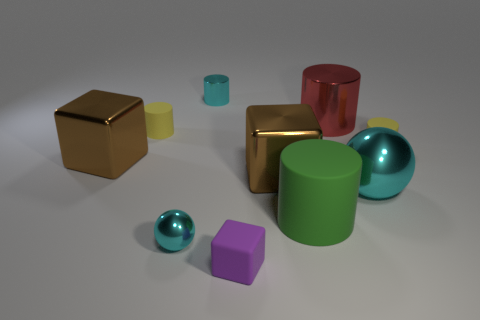Subtract all big blocks. How many blocks are left? 1 Subtract all purple blocks. How many yellow cylinders are left? 2 Subtract all cyan cylinders. How many cylinders are left? 4 Subtract all spheres. How many objects are left? 8 Add 1 small yellow objects. How many small yellow objects are left? 3 Add 4 large brown cubes. How many large brown cubes exist? 6 Subtract 0 yellow blocks. How many objects are left? 10 Subtract all red blocks. Subtract all red balls. How many blocks are left? 3 Subtract all large cubes. Subtract all cylinders. How many objects are left? 3 